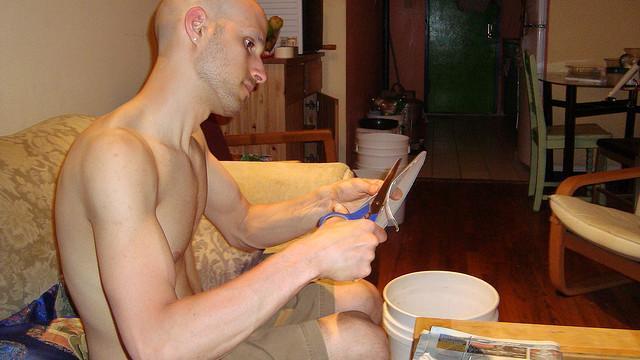How many dining tables can be seen?
Give a very brief answer. 2. How many chairs are visible?
Give a very brief answer. 3. How many refrigerators are there?
Give a very brief answer. 2. 